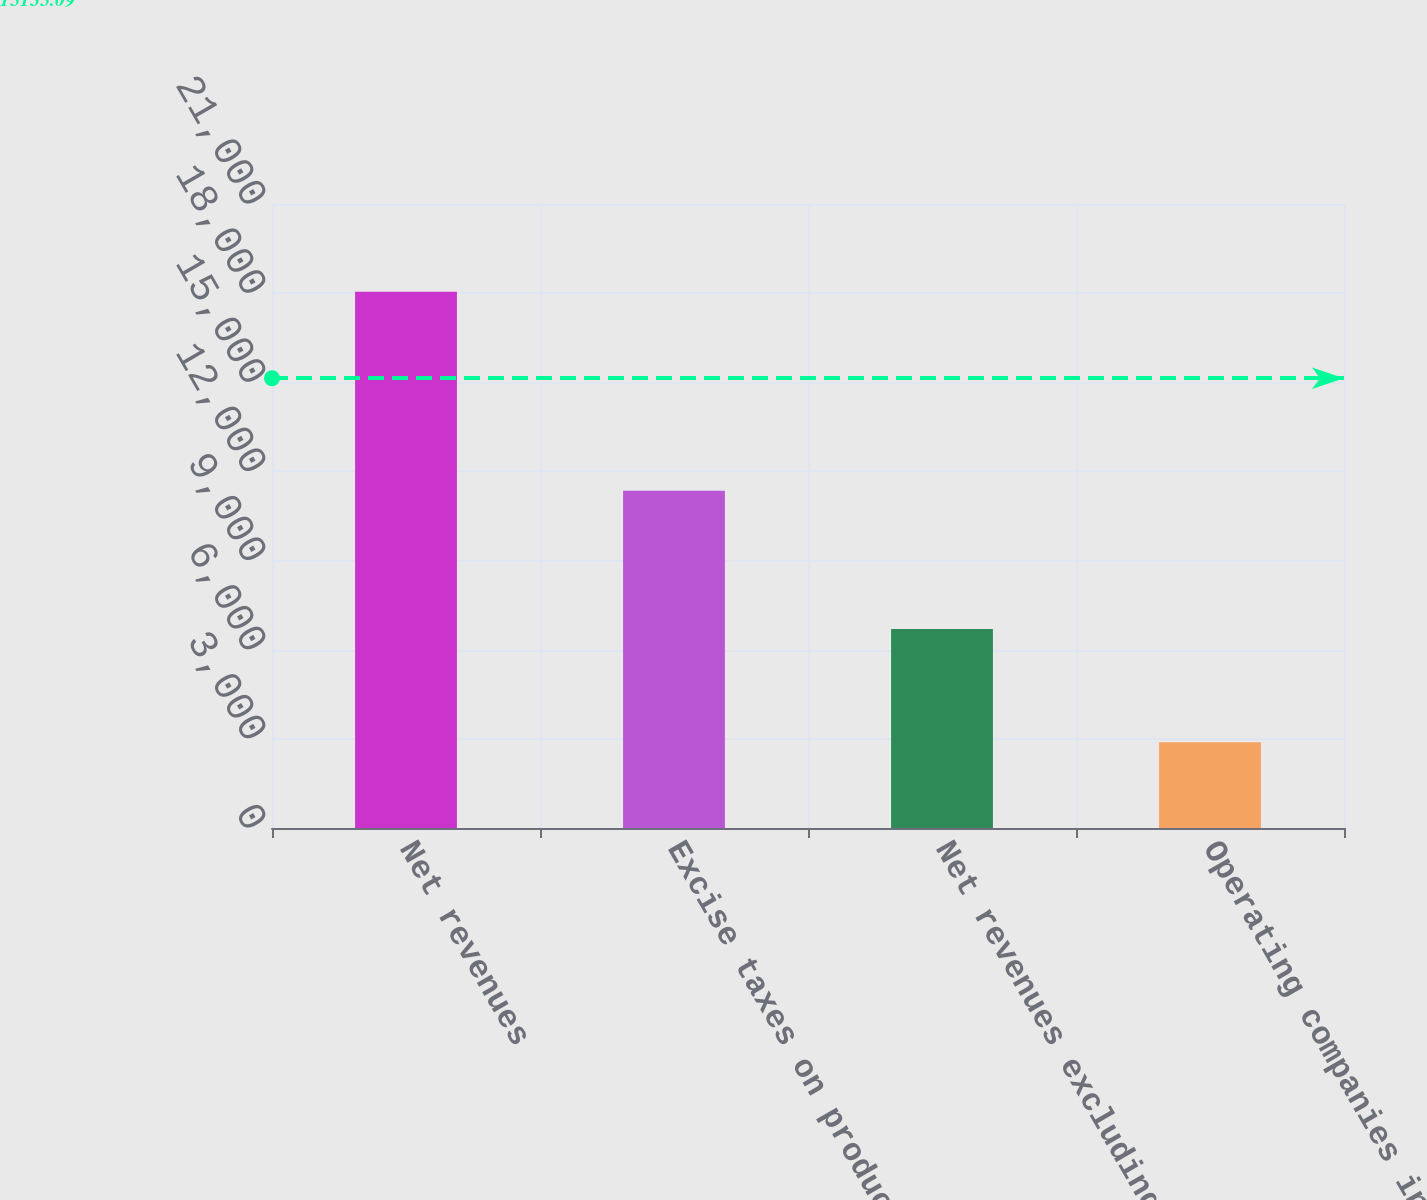<chart> <loc_0><loc_0><loc_500><loc_500><bar_chart><fcel>Net revenues<fcel>Excise taxes on products<fcel>Net revenues excluding excise<fcel>Operating companies income<nl><fcel>18045<fcel>11346<fcel>6699<fcel>2888<nl></chart> 